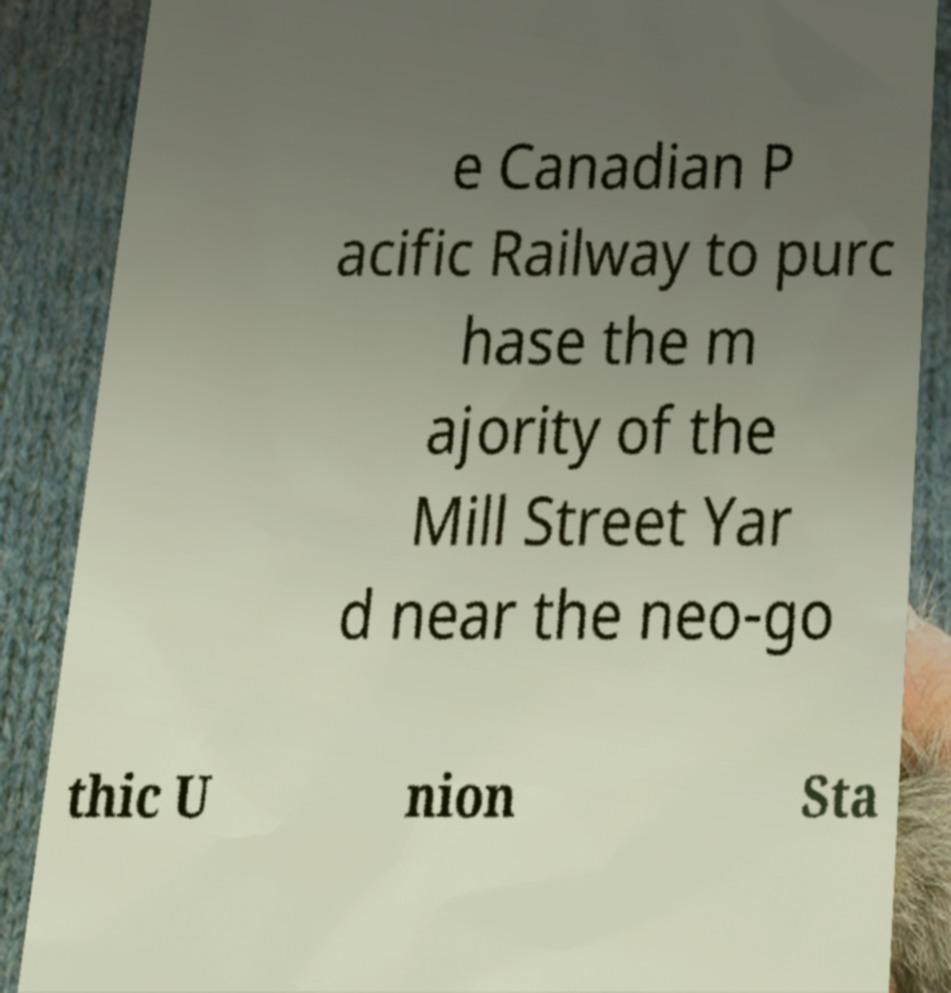Could you assist in decoding the text presented in this image and type it out clearly? e Canadian P acific Railway to purc hase the m ajority of the Mill Street Yar d near the neo-go thic U nion Sta 